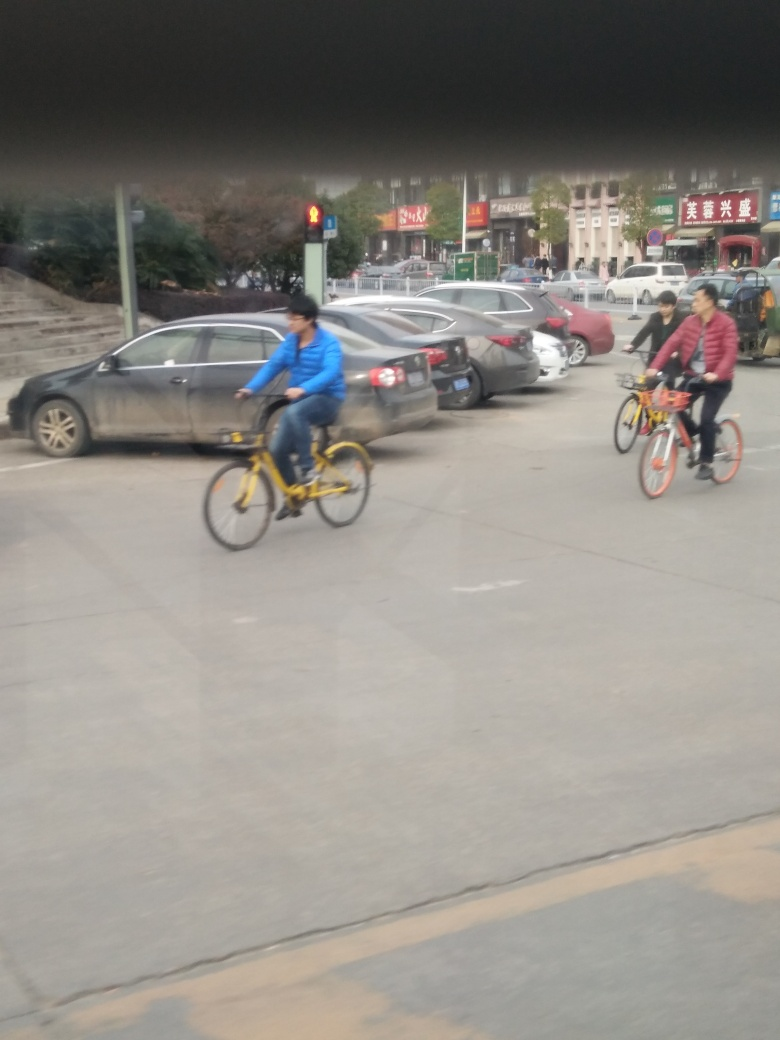Is the sharpness of the ground acceptable? The ground in the image appears somewhat blurry, indicating a lack of sharpness which could be due to motion blur or a low-quality camera lens. It's important for the details such as textures and markings on the road to be clear for better visual interpretation. 